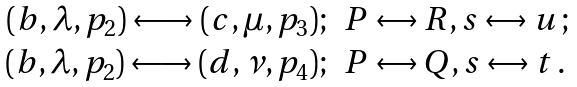Convert formula to latex. <formula><loc_0><loc_0><loc_500><loc_500>\begin{array} { r l } { { ( b , \lambda , p _ { 2 } ) \longleftrightarrow ( c , \mu , p _ { 3 } ) ; } } & { P \leftrightarrow R , s \leftrightarrow u \, ; } \\ { { ( b , \lambda , p _ { 2 } ) \longleftrightarrow ( d , \nu , p _ { 4 } ) ; } } & { P \leftrightarrow Q , s \leftrightarrow t \, . } \end{array}</formula> 